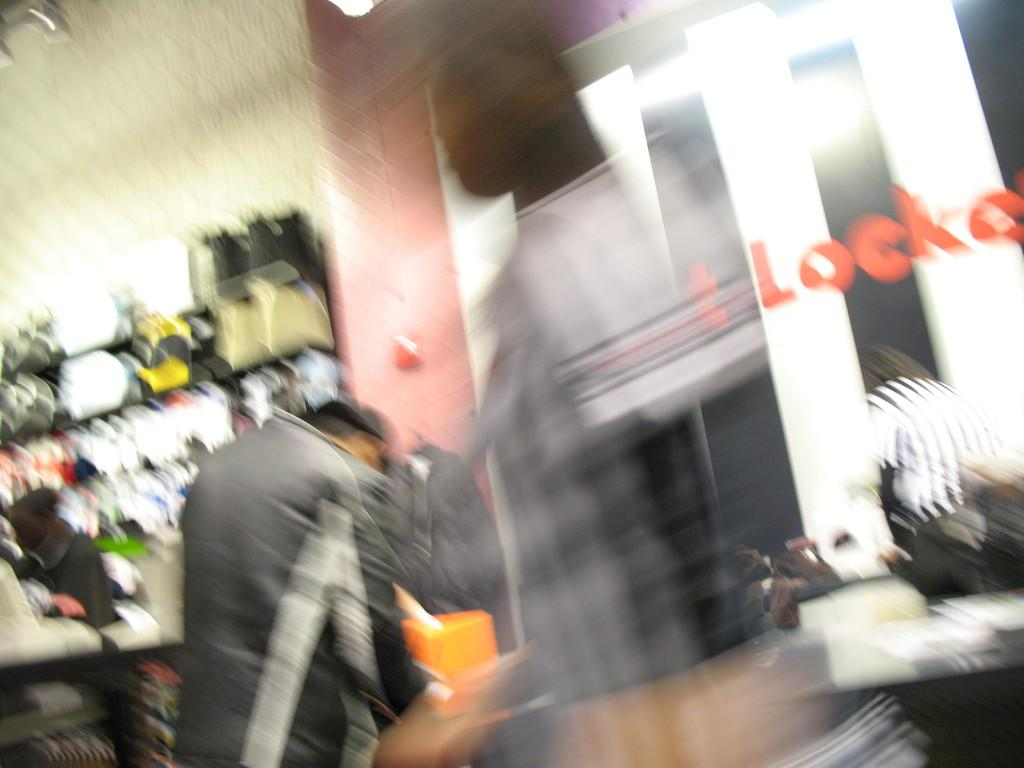How many people are in the image? The number of people in the image cannot be determined from the provided fact. What type of bike is being used by the people in the image? There is no bike present in the image, as the fact only mentions that there are people in the image. 